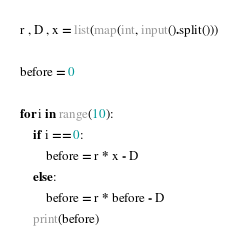Convert code to text. <code><loc_0><loc_0><loc_500><loc_500><_Python_>r , D , x = list(map(int, input().split()))

before = 0

for i in range(10):
    if i == 0:
        before = r * x - D
    else:
        before = r * before - D
    print(before)</code> 